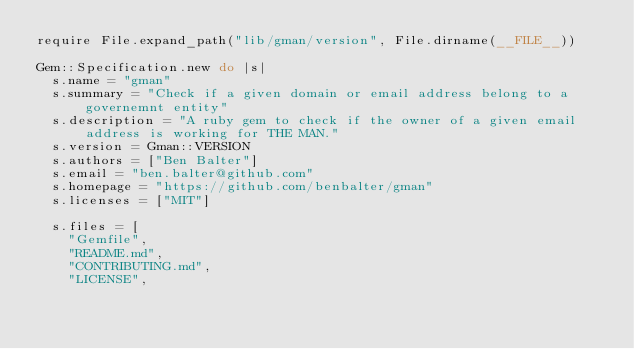<code> <loc_0><loc_0><loc_500><loc_500><_Ruby_>require File.expand_path("lib/gman/version", File.dirname(__FILE__))

Gem::Specification.new do |s|
  s.name = "gman"
  s.summary = "Check if a given domain or email address belong to a governemnt entity"
  s.description = "A ruby gem to check if the owner of a given email address is working for THE MAN."
  s.version = Gman::VERSION
  s.authors = ["Ben Balter"]
  s.email = "ben.balter@github.com"
  s.homepage = "https://github.com/benbalter/gman"
  s.licenses = ["MIT"]

  s.files = [
    "Gemfile",
    "README.md",
    "CONTRIBUTING.md",
    "LICENSE",</code> 